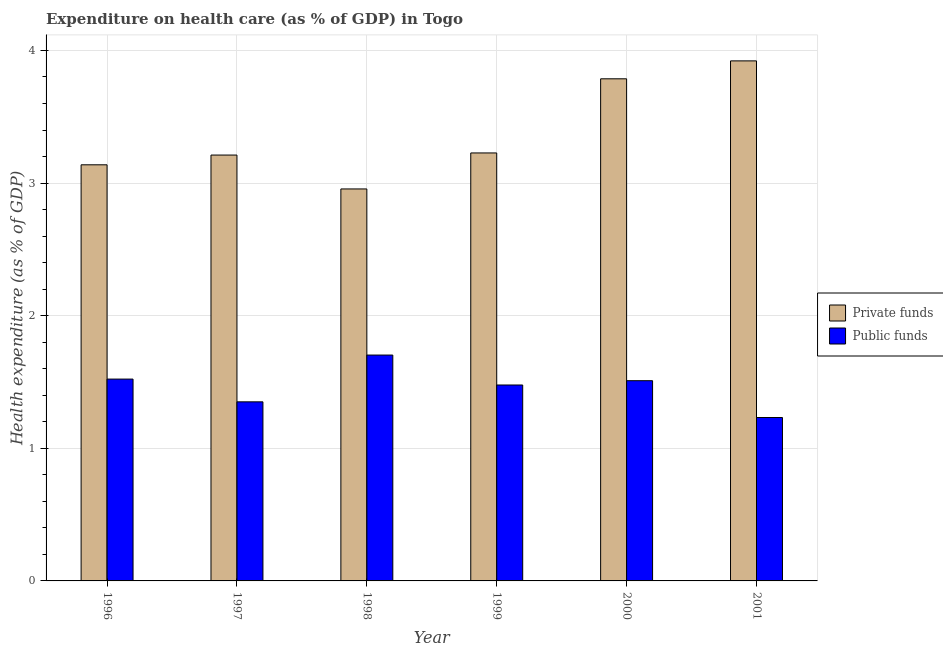Are the number of bars per tick equal to the number of legend labels?
Ensure brevity in your answer.  Yes. How many bars are there on the 3rd tick from the right?
Give a very brief answer. 2. What is the amount of public funds spent in healthcare in 1999?
Ensure brevity in your answer.  1.48. Across all years, what is the maximum amount of public funds spent in healthcare?
Your answer should be compact. 1.7. Across all years, what is the minimum amount of public funds spent in healthcare?
Keep it short and to the point. 1.23. In which year was the amount of private funds spent in healthcare minimum?
Keep it short and to the point. 1998. What is the total amount of public funds spent in healthcare in the graph?
Provide a short and direct response. 8.79. What is the difference between the amount of public funds spent in healthcare in 1996 and that in 1999?
Provide a short and direct response. 0.04. What is the difference between the amount of public funds spent in healthcare in 1996 and the amount of private funds spent in healthcare in 2001?
Ensure brevity in your answer.  0.29. What is the average amount of public funds spent in healthcare per year?
Offer a terse response. 1.47. In how many years, is the amount of private funds spent in healthcare greater than 0.6000000000000001 %?
Provide a short and direct response. 6. What is the ratio of the amount of public funds spent in healthcare in 1999 to that in 2000?
Your response must be concise. 0.98. Is the amount of private funds spent in healthcare in 1997 less than that in 2000?
Provide a succinct answer. Yes. Is the difference between the amount of public funds spent in healthcare in 1996 and 1999 greater than the difference between the amount of private funds spent in healthcare in 1996 and 1999?
Offer a terse response. No. What is the difference between the highest and the second highest amount of private funds spent in healthcare?
Offer a very short reply. 0.14. What is the difference between the highest and the lowest amount of private funds spent in healthcare?
Your answer should be very brief. 0.97. In how many years, is the amount of public funds spent in healthcare greater than the average amount of public funds spent in healthcare taken over all years?
Make the answer very short. 4. Is the sum of the amount of public funds spent in healthcare in 1996 and 2000 greater than the maximum amount of private funds spent in healthcare across all years?
Provide a short and direct response. Yes. What does the 2nd bar from the left in 1998 represents?
Ensure brevity in your answer.  Public funds. What does the 1st bar from the right in 1996 represents?
Your response must be concise. Public funds. How many bars are there?
Ensure brevity in your answer.  12. Are all the bars in the graph horizontal?
Offer a terse response. No. What is the difference between two consecutive major ticks on the Y-axis?
Provide a short and direct response. 1. Does the graph contain any zero values?
Keep it short and to the point. No. Does the graph contain grids?
Your response must be concise. Yes. How many legend labels are there?
Ensure brevity in your answer.  2. How are the legend labels stacked?
Your answer should be compact. Vertical. What is the title of the graph?
Keep it short and to the point. Expenditure on health care (as % of GDP) in Togo. What is the label or title of the Y-axis?
Your response must be concise. Health expenditure (as % of GDP). What is the Health expenditure (as % of GDP) of Private funds in 1996?
Give a very brief answer. 3.14. What is the Health expenditure (as % of GDP) in Public funds in 1996?
Keep it short and to the point. 1.52. What is the Health expenditure (as % of GDP) of Private funds in 1997?
Offer a terse response. 3.21. What is the Health expenditure (as % of GDP) of Public funds in 1997?
Your response must be concise. 1.35. What is the Health expenditure (as % of GDP) in Private funds in 1998?
Your answer should be compact. 2.96. What is the Health expenditure (as % of GDP) of Public funds in 1998?
Give a very brief answer. 1.7. What is the Health expenditure (as % of GDP) in Private funds in 1999?
Provide a succinct answer. 3.23. What is the Health expenditure (as % of GDP) of Public funds in 1999?
Offer a very short reply. 1.48. What is the Health expenditure (as % of GDP) of Private funds in 2000?
Offer a very short reply. 3.79. What is the Health expenditure (as % of GDP) in Public funds in 2000?
Provide a short and direct response. 1.51. What is the Health expenditure (as % of GDP) of Private funds in 2001?
Your answer should be very brief. 3.92. What is the Health expenditure (as % of GDP) in Public funds in 2001?
Give a very brief answer. 1.23. Across all years, what is the maximum Health expenditure (as % of GDP) of Private funds?
Offer a very short reply. 3.92. Across all years, what is the maximum Health expenditure (as % of GDP) of Public funds?
Ensure brevity in your answer.  1.7. Across all years, what is the minimum Health expenditure (as % of GDP) of Private funds?
Keep it short and to the point. 2.96. Across all years, what is the minimum Health expenditure (as % of GDP) in Public funds?
Make the answer very short. 1.23. What is the total Health expenditure (as % of GDP) in Private funds in the graph?
Keep it short and to the point. 20.24. What is the total Health expenditure (as % of GDP) of Public funds in the graph?
Your answer should be compact. 8.79. What is the difference between the Health expenditure (as % of GDP) in Private funds in 1996 and that in 1997?
Make the answer very short. -0.07. What is the difference between the Health expenditure (as % of GDP) in Public funds in 1996 and that in 1997?
Make the answer very short. 0.17. What is the difference between the Health expenditure (as % of GDP) of Private funds in 1996 and that in 1998?
Offer a terse response. 0.18. What is the difference between the Health expenditure (as % of GDP) in Public funds in 1996 and that in 1998?
Make the answer very short. -0.18. What is the difference between the Health expenditure (as % of GDP) in Private funds in 1996 and that in 1999?
Offer a terse response. -0.09. What is the difference between the Health expenditure (as % of GDP) in Public funds in 1996 and that in 1999?
Provide a short and direct response. 0.04. What is the difference between the Health expenditure (as % of GDP) in Private funds in 1996 and that in 2000?
Make the answer very short. -0.65. What is the difference between the Health expenditure (as % of GDP) in Public funds in 1996 and that in 2000?
Give a very brief answer. 0.01. What is the difference between the Health expenditure (as % of GDP) in Private funds in 1996 and that in 2001?
Your answer should be compact. -0.78. What is the difference between the Health expenditure (as % of GDP) of Public funds in 1996 and that in 2001?
Make the answer very short. 0.29. What is the difference between the Health expenditure (as % of GDP) of Private funds in 1997 and that in 1998?
Your answer should be very brief. 0.26. What is the difference between the Health expenditure (as % of GDP) in Public funds in 1997 and that in 1998?
Your answer should be very brief. -0.35. What is the difference between the Health expenditure (as % of GDP) in Private funds in 1997 and that in 1999?
Offer a terse response. -0.02. What is the difference between the Health expenditure (as % of GDP) of Public funds in 1997 and that in 1999?
Give a very brief answer. -0.13. What is the difference between the Health expenditure (as % of GDP) in Private funds in 1997 and that in 2000?
Ensure brevity in your answer.  -0.57. What is the difference between the Health expenditure (as % of GDP) of Public funds in 1997 and that in 2000?
Your answer should be very brief. -0.16. What is the difference between the Health expenditure (as % of GDP) in Private funds in 1997 and that in 2001?
Ensure brevity in your answer.  -0.71. What is the difference between the Health expenditure (as % of GDP) of Public funds in 1997 and that in 2001?
Keep it short and to the point. 0.12. What is the difference between the Health expenditure (as % of GDP) of Private funds in 1998 and that in 1999?
Provide a succinct answer. -0.27. What is the difference between the Health expenditure (as % of GDP) of Public funds in 1998 and that in 1999?
Provide a short and direct response. 0.23. What is the difference between the Health expenditure (as % of GDP) in Private funds in 1998 and that in 2000?
Provide a succinct answer. -0.83. What is the difference between the Health expenditure (as % of GDP) of Public funds in 1998 and that in 2000?
Your answer should be very brief. 0.19. What is the difference between the Health expenditure (as % of GDP) of Private funds in 1998 and that in 2001?
Provide a succinct answer. -0.97. What is the difference between the Health expenditure (as % of GDP) in Public funds in 1998 and that in 2001?
Give a very brief answer. 0.47. What is the difference between the Health expenditure (as % of GDP) of Private funds in 1999 and that in 2000?
Your answer should be very brief. -0.56. What is the difference between the Health expenditure (as % of GDP) in Public funds in 1999 and that in 2000?
Offer a terse response. -0.03. What is the difference between the Health expenditure (as % of GDP) of Private funds in 1999 and that in 2001?
Your response must be concise. -0.69. What is the difference between the Health expenditure (as % of GDP) in Public funds in 1999 and that in 2001?
Provide a short and direct response. 0.25. What is the difference between the Health expenditure (as % of GDP) of Private funds in 2000 and that in 2001?
Provide a succinct answer. -0.14. What is the difference between the Health expenditure (as % of GDP) in Public funds in 2000 and that in 2001?
Give a very brief answer. 0.28. What is the difference between the Health expenditure (as % of GDP) of Private funds in 1996 and the Health expenditure (as % of GDP) of Public funds in 1997?
Keep it short and to the point. 1.79. What is the difference between the Health expenditure (as % of GDP) in Private funds in 1996 and the Health expenditure (as % of GDP) in Public funds in 1998?
Give a very brief answer. 1.43. What is the difference between the Health expenditure (as % of GDP) of Private funds in 1996 and the Health expenditure (as % of GDP) of Public funds in 1999?
Keep it short and to the point. 1.66. What is the difference between the Health expenditure (as % of GDP) of Private funds in 1996 and the Health expenditure (as % of GDP) of Public funds in 2000?
Offer a terse response. 1.63. What is the difference between the Health expenditure (as % of GDP) of Private funds in 1996 and the Health expenditure (as % of GDP) of Public funds in 2001?
Provide a short and direct response. 1.91. What is the difference between the Health expenditure (as % of GDP) in Private funds in 1997 and the Health expenditure (as % of GDP) in Public funds in 1998?
Provide a succinct answer. 1.51. What is the difference between the Health expenditure (as % of GDP) in Private funds in 1997 and the Health expenditure (as % of GDP) in Public funds in 1999?
Offer a very short reply. 1.73. What is the difference between the Health expenditure (as % of GDP) in Private funds in 1997 and the Health expenditure (as % of GDP) in Public funds in 2000?
Offer a very short reply. 1.7. What is the difference between the Health expenditure (as % of GDP) of Private funds in 1997 and the Health expenditure (as % of GDP) of Public funds in 2001?
Your answer should be very brief. 1.98. What is the difference between the Health expenditure (as % of GDP) of Private funds in 1998 and the Health expenditure (as % of GDP) of Public funds in 1999?
Provide a succinct answer. 1.48. What is the difference between the Health expenditure (as % of GDP) in Private funds in 1998 and the Health expenditure (as % of GDP) in Public funds in 2000?
Your answer should be compact. 1.45. What is the difference between the Health expenditure (as % of GDP) in Private funds in 1998 and the Health expenditure (as % of GDP) in Public funds in 2001?
Offer a terse response. 1.72. What is the difference between the Health expenditure (as % of GDP) in Private funds in 1999 and the Health expenditure (as % of GDP) in Public funds in 2000?
Make the answer very short. 1.72. What is the difference between the Health expenditure (as % of GDP) of Private funds in 1999 and the Health expenditure (as % of GDP) of Public funds in 2001?
Provide a succinct answer. 2. What is the difference between the Health expenditure (as % of GDP) of Private funds in 2000 and the Health expenditure (as % of GDP) of Public funds in 2001?
Provide a succinct answer. 2.55. What is the average Health expenditure (as % of GDP) of Private funds per year?
Your response must be concise. 3.37. What is the average Health expenditure (as % of GDP) in Public funds per year?
Ensure brevity in your answer.  1.47. In the year 1996, what is the difference between the Health expenditure (as % of GDP) in Private funds and Health expenditure (as % of GDP) in Public funds?
Provide a short and direct response. 1.62. In the year 1997, what is the difference between the Health expenditure (as % of GDP) of Private funds and Health expenditure (as % of GDP) of Public funds?
Provide a short and direct response. 1.86. In the year 1998, what is the difference between the Health expenditure (as % of GDP) in Private funds and Health expenditure (as % of GDP) in Public funds?
Offer a very short reply. 1.25. In the year 1999, what is the difference between the Health expenditure (as % of GDP) in Private funds and Health expenditure (as % of GDP) in Public funds?
Your answer should be compact. 1.75. In the year 2000, what is the difference between the Health expenditure (as % of GDP) of Private funds and Health expenditure (as % of GDP) of Public funds?
Provide a succinct answer. 2.28. In the year 2001, what is the difference between the Health expenditure (as % of GDP) in Private funds and Health expenditure (as % of GDP) in Public funds?
Ensure brevity in your answer.  2.69. What is the ratio of the Health expenditure (as % of GDP) of Private funds in 1996 to that in 1997?
Your answer should be compact. 0.98. What is the ratio of the Health expenditure (as % of GDP) of Public funds in 1996 to that in 1997?
Your response must be concise. 1.13. What is the ratio of the Health expenditure (as % of GDP) in Private funds in 1996 to that in 1998?
Your answer should be very brief. 1.06. What is the ratio of the Health expenditure (as % of GDP) of Public funds in 1996 to that in 1998?
Your response must be concise. 0.89. What is the ratio of the Health expenditure (as % of GDP) in Private funds in 1996 to that in 1999?
Offer a terse response. 0.97. What is the ratio of the Health expenditure (as % of GDP) in Public funds in 1996 to that in 1999?
Keep it short and to the point. 1.03. What is the ratio of the Health expenditure (as % of GDP) of Private funds in 1996 to that in 2000?
Ensure brevity in your answer.  0.83. What is the ratio of the Health expenditure (as % of GDP) of Private funds in 1996 to that in 2001?
Keep it short and to the point. 0.8. What is the ratio of the Health expenditure (as % of GDP) in Public funds in 1996 to that in 2001?
Your response must be concise. 1.24. What is the ratio of the Health expenditure (as % of GDP) of Private funds in 1997 to that in 1998?
Offer a very short reply. 1.09. What is the ratio of the Health expenditure (as % of GDP) in Public funds in 1997 to that in 1998?
Ensure brevity in your answer.  0.79. What is the ratio of the Health expenditure (as % of GDP) of Private funds in 1997 to that in 1999?
Offer a terse response. 1. What is the ratio of the Health expenditure (as % of GDP) of Public funds in 1997 to that in 1999?
Your answer should be very brief. 0.91. What is the ratio of the Health expenditure (as % of GDP) in Private funds in 1997 to that in 2000?
Provide a short and direct response. 0.85. What is the ratio of the Health expenditure (as % of GDP) in Public funds in 1997 to that in 2000?
Keep it short and to the point. 0.89. What is the ratio of the Health expenditure (as % of GDP) in Private funds in 1997 to that in 2001?
Your answer should be compact. 0.82. What is the ratio of the Health expenditure (as % of GDP) of Public funds in 1997 to that in 2001?
Keep it short and to the point. 1.1. What is the ratio of the Health expenditure (as % of GDP) of Private funds in 1998 to that in 1999?
Ensure brevity in your answer.  0.92. What is the ratio of the Health expenditure (as % of GDP) of Public funds in 1998 to that in 1999?
Offer a terse response. 1.15. What is the ratio of the Health expenditure (as % of GDP) in Private funds in 1998 to that in 2000?
Give a very brief answer. 0.78. What is the ratio of the Health expenditure (as % of GDP) in Public funds in 1998 to that in 2000?
Make the answer very short. 1.13. What is the ratio of the Health expenditure (as % of GDP) of Private funds in 1998 to that in 2001?
Your answer should be very brief. 0.75. What is the ratio of the Health expenditure (as % of GDP) in Public funds in 1998 to that in 2001?
Give a very brief answer. 1.38. What is the ratio of the Health expenditure (as % of GDP) in Private funds in 1999 to that in 2000?
Ensure brevity in your answer.  0.85. What is the ratio of the Health expenditure (as % of GDP) of Public funds in 1999 to that in 2000?
Provide a short and direct response. 0.98. What is the ratio of the Health expenditure (as % of GDP) of Private funds in 1999 to that in 2001?
Keep it short and to the point. 0.82. What is the ratio of the Health expenditure (as % of GDP) of Public funds in 1999 to that in 2001?
Offer a terse response. 1.2. What is the ratio of the Health expenditure (as % of GDP) in Private funds in 2000 to that in 2001?
Make the answer very short. 0.97. What is the ratio of the Health expenditure (as % of GDP) of Public funds in 2000 to that in 2001?
Keep it short and to the point. 1.23. What is the difference between the highest and the second highest Health expenditure (as % of GDP) of Private funds?
Your response must be concise. 0.14. What is the difference between the highest and the second highest Health expenditure (as % of GDP) of Public funds?
Your response must be concise. 0.18. What is the difference between the highest and the lowest Health expenditure (as % of GDP) of Private funds?
Offer a terse response. 0.97. What is the difference between the highest and the lowest Health expenditure (as % of GDP) of Public funds?
Make the answer very short. 0.47. 